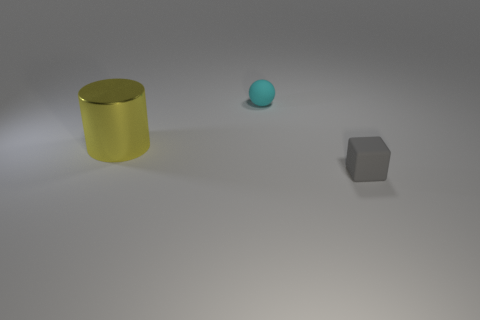Are there any other things that are the same size as the cylinder?
Provide a succinct answer. No. Are there any other things that have the same material as the cylinder?
Your response must be concise. No. The thing that is in front of the cyan matte object and behind the small gray matte block is what color?
Offer a very short reply. Yellow. Is the material of the small cyan ball the same as the small object that is in front of the metal object?
Provide a succinct answer. Yes. Are there fewer tiny objects that are on the right side of the cyan matte thing than cyan objects?
Keep it short and to the point. No. How many other things are there of the same shape as the tiny cyan object?
Your answer should be compact. 0. Is there any other thing that has the same color as the large cylinder?
Give a very brief answer. No. What number of other objects are the same size as the cyan rubber object?
Your answer should be very brief. 1. How many cubes are either big yellow metal objects or small yellow things?
Your answer should be compact. 0. There is a small matte object behind the big yellow cylinder; does it have the same shape as the tiny gray object?
Your answer should be compact. No. 